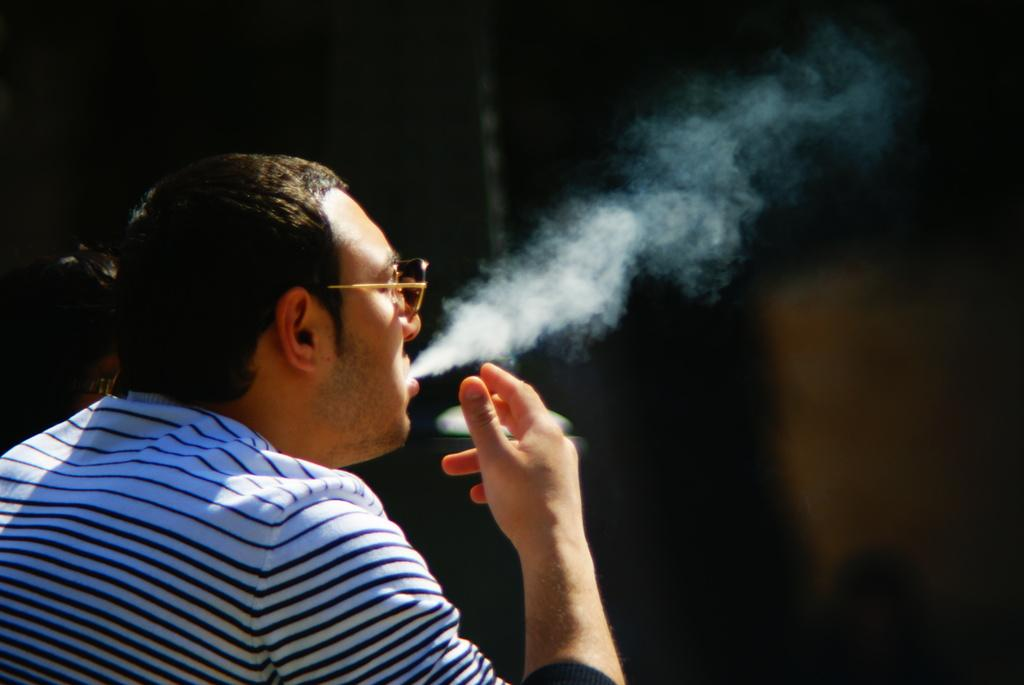Who is present in the image? There is a man in the image. Where is the man located in the image? The man is on the left side of the image. What is the man wearing in the image? The man is wearing a T-shirt in the image. What else can be seen in the image besides the man? There is smoke visible in the image. What type of turkey is being cooked in the image? There is no turkey present in the image; it only features a man and smoke. How many quivers can be seen in the image? There are no quivers present in the image. 